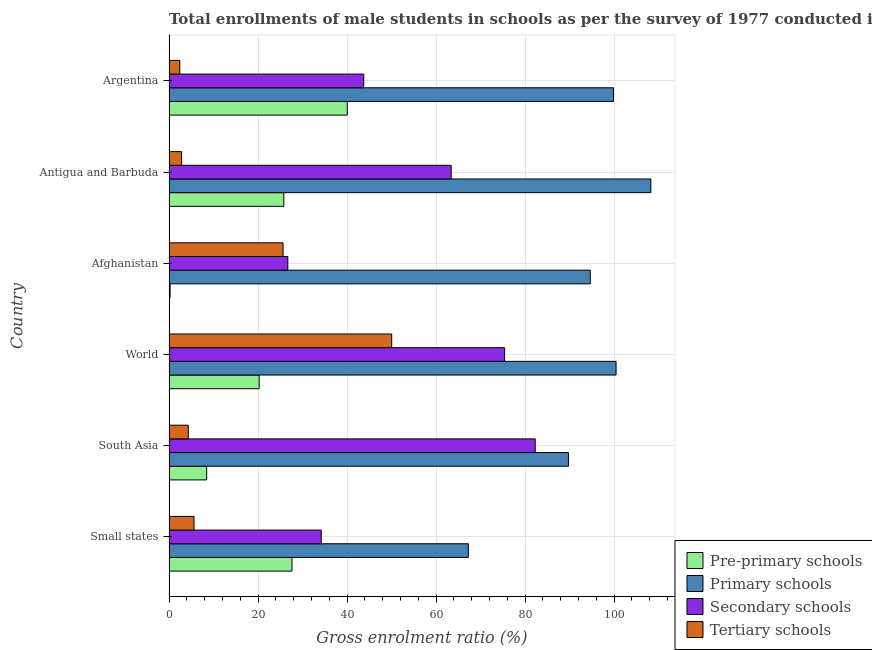How many groups of bars are there?
Give a very brief answer. 6. Are the number of bars per tick equal to the number of legend labels?
Make the answer very short. Yes. Are the number of bars on each tick of the Y-axis equal?
Your response must be concise. Yes. How many bars are there on the 3rd tick from the bottom?
Provide a succinct answer. 4. In how many cases, is the number of bars for a given country not equal to the number of legend labels?
Keep it short and to the point. 0. What is the gross enrolment ratio(male) in secondary schools in Small states?
Offer a terse response. 34.22. Across all countries, what is the maximum gross enrolment ratio(male) in tertiary schools?
Make the answer very short. 50.04. Across all countries, what is the minimum gross enrolment ratio(male) in secondary schools?
Your answer should be compact. 26.7. In which country was the gross enrolment ratio(male) in secondary schools minimum?
Provide a short and direct response. Afghanistan. What is the total gross enrolment ratio(male) in primary schools in the graph?
Ensure brevity in your answer.  560.32. What is the difference between the gross enrolment ratio(male) in pre-primary schools in Argentina and that in World?
Your answer should be very brief. 19.8. What is the difference between the gross enrolment ratio(male) in primary schools in South Asia and the gross enrolment ratio(male) in pre-primary schools in World?
Your response must be concise. 69.5. What is the average gross enrolment ratio(male) in tertiary schools per country?
Make the answer very short. 15.15. What is the difference between the gross enrolment ratio(male) in pre-primary schools and gross enrolment ratio(male) in tertiary schools in Antigua and Barbuda?
Offer a very short reply. 22.97. In how many countries, is the gross enrolment ratio(male) in pre-primary schools greater than 92 %?
Make the answer very short. 0. What is the ratio of the gross enrolment ratio(male) in primary schools in Antigua and Barbuda to that in Small states?
Ensure brevity in your answer.  1.61. Is the gross enrolment ratio(male) in pre-primary schools in Antigua and Barbuda less than that in Small states?
Your answer should be compact. Yes. What is the difference between the highest and the second highest gross enrolment ratio(male) in pre-primary schools?
Ensure brevity in your answer.  12.43. What is the difference between the highest and the lowest gross enrolment ratio(male) in secondary schools?
Keep it short and to the point. 55.6. In how many countries, is the gross enrolment ratio(male) in tertiary schools greater than the average gross enrolment ratio(male) in tertiary schools taken over all countries?
Provide a succinct answer. 2. Is it the case that in every country, the sum of the gross enrolment ratio(male) in secondary schools and gross enrolment ratio(male) in pre-primary schools is greater than the sum of gross enrolment ratio(male) in primary schools and gross enrolment ratio(male) in tertiary schools?
Your response must be concise. Yes. What does the 1st bar from the top in South Asia represents?
Offer a very short reply. Tertiary schools. What does the 2nd bar from the bottom in World represents?
Keep it short and to the point. Primary schools. How many bars are there?
Provide a succinct answer. 24. Does the graph contain any zero values?
Provide a short and direct response. No. Does the graph contain grids?
Offer a terse response. Yes. Where does the legend appear in the graph?
Ensure brevity in your answer.  Bottom right. How are the legend labels stacked?
Make the answer very short. Vertical. What is the title of the graph?
Offer a very short reply. Total enrollments of male students in schools as per the survey of 1977 conducted in different countries. What is the label or title of the X-axis?
Give a very brief answer. Gross enrolment ratio (%). What is the label or title of the Y-axis?
Your answer should be compact. Country. What is the Gross enrolment ratio (%) in Pre-primary schools in Small states?
Give a very brief answer. 27.63. What is the Gross enrolment ratio (%) of Primary schools in Small states?
Your answer should be very brief. 67.26. What is the Gross enrolment ratio (%) in Secondary schools in Small states?
Ensure brevity in your answer.  34.22. What is the Gross enrolment ratio (%) in Tertiary schools in Small states?
Offer a terse response. 5.62. What is the Gross enrolment ratio (%) in Pre-primary schools in South Asia?
Your answer should be compact. 8.46. What is the Gross enrolment ratio (%) of Primary schools in South Asia?
Your answer should be compact. 89.76. What is the Gross enrolment ratio (%) in Secondary schools in South Asia?
Keep it short and to the point. 82.29. What is the Gross enrolment ratio (%) of Tertiary schools in South Asia?
Offer a terse response. 4.33. What is the Gross enrolment ratio (%) of Pre-primary schools in World?
Provide a short and direct response. 20.26. What is the Gross enrolment ratio (%) of Primary schools in World?
Offer a terse response. 100.46. What is the Gross enrolment ratio (%) of Secondary schools in World?
Provide a succinct answer. 75.41. What is the Gross enrolment ratio (%) of Tertiary schools in World?
Give a very brief answer. 50.04. What is the Gross enrolment ratio (%) in Pre-primary schools in Afghanistan?
Make the answer very short. 0.25. What is the Gross enrolment ratio (%) in Primary schools in Afghanistan?
Give a very brief answer. 94.66. What is the Gross enrolment ratio (%) of Secondary schools in Afghanistan?
Provide a short and direct response. 26.7. What is the Gross enrolment ratio (%) of Tertiary schools in Afghanistan?
Your answer should be compact. 25.63. What is the Gross enrolment ratio (%) in Pre-primary schools in Antigua and Barbuda?
Keep it short and to the point. 25.8. What is the Gross enrolment ratio (%) in Primary schools in Antigua and Barbuda?
Give a very brief answer. 108.28. What is the Gross enrolment ratio (%) of Secondary schools in Antigua and Barbuda?
Provide a succinct answer. 63.41. What is the Gross enrolment ratio (%) of Tertiary schools in Antigua and Barbuda?
Offer a terse response. 2.84. What is the Gross enrolment ratio (%) in Pre-primary schools in Argentina?
Keep it short and to the point. 40.06. What is the Gross enrolment ratio (%) in Primary schools in Argentina?
Make the answer very short. 99.88. What is the Gross enrolment ratio (%) in Secondary schools in Argentina?
Keep it short and to the point. 43.76. What is the Gross enrolment ratio (%) in Tertiary schools in Argentina?
Your response must be concise. 2.43. Across all countries, what is the maximum Gross enrolment ratio (%) of Pre-primary schools?
Provide a short and direct response. 40.06. Across all countries, what is the maximum Gross enrolment ratio (%) in Primary schools?
Make the answer very short. 108.28. Across all countries, what is the maximum Gross enrolment ratio (%) of Secondary schools?
Give a very brief answer. 82.29. Across all countries, what is the maximum Gross enrolment ratio (%) in Tertiary schools?
Your response must be concise. 50.04. Across all countries, what is the minimum Gross enrolment ratio (%) in Pre-primary schools?
Your answer should be very brief. 0.25. Across all countries, what is the minimum Gross enrolment ratio (%) in Primary schools?
Offer a very short reply. 67.26. Across all countries, what is the minimum Gross enrolment ratio (%) in Secondary schools?
Keep it short and to the point. 26.7. Across all countries, what is the minimum Gross enrolment ratio (%) in Tertiary schools?
Your answer should be compact. 2.43. What is the total Gross enrolment ratio (%) in Pre-primary schools in the graph?
Provide a short and direct response. 122.47. What is the total Gross enrolment ratio (%) of Primary schools in the graph?
Your answer should be compact. 560.32. What is the total Gross enrolment ratio (%) of Secondary schools in the graph?
Provide a succinct answer. 325.79. What is the total Gross enrolment ratio (%) of Tertiary schools in the graph?
Make the answer very short. 90.89. What is the difference between the Gross enrolment ratio (%) of Pre-primary schools in Small states and that in South Asia?
Provide a short and direct response. 19.17. What is the difference between the Gross enrolment ratio (%) of Primary schools in Small states and that in South Asia?
Your answer should be compact. -22.51. What is the difference between the Gross enrolment ratio (%) of Secondary schools in Small states and that in South Asia?
Offer a terse response. -48.08. What is the difference between the Gross enrolment ratio (%) in Tertiary schools in Small states and that in South Asia?
Your response must be concise. 1.29. What is the difference between the Gross enrolment ratio (%) in Pre-primary schools in Small states and that in World?
Make the answer very short. 7.37. What is the difference between the Gross enrolment ratio (%) in Primary schools in Small states and that in World?
Your response must be concise. -33.21. What is the difference between the Gross enrolment ratio (%) of Secondary schools in Small states and that in World?
Make the answer very short. -41.2. What is the difference between the Gross enrolment ratio (%) in Tertiary schools in Small states and that in World?
Make the answer very short. -44.42. What is the difference between the Gross enrolment ratio (%) in Pre-primary schools in Small states and that in Afghanistan?
Provide a succinct answer. 27.38. What is the difference between the Gross enrolment ratio (%) of Primary schools in Small states and that in Afghanistan?
Your answer should be compact. -27.41. What is the difference between the Gross enrolment ratio (%) in Secondary schools in Small states and that in Afghanistan?
Your answer should be very brief. 7.52. What is the difference between the Gross enrolment ratio (%) of Tertiary schools in Small states and that in Afghanistan?
Give a very brief answer. -20.01. What is the difference between the Gross enrolment ratio (%) in Pre-primary schools in Small states and that in Antigua and Barbuda?
Your answer should be very brief. 1.82. What is the difference between the Gross enrolment ratio (%) in Primary schools in Small states and that in Antigua and Barbuda?
Provide a short and direct response. -41.03. What is the difference between the Gross enrolment ratio (%) of Secondary schools in Small states and that in Antigua and Barbuda?
Provide a succinct answer. -29.19. What is the difference between the Gross enrolment ratio (%) in Tertiary schools in Small states and that in Antigua and Barbuda?
Provide a succinct answer. 2.78. What is the difference between the Gross enrolment ratio (%) of Pre-primary schools in Small states and that in Argentina?
Offer a terse response. -12.43. What is the difference between the Gross enrolment ratio (%) of Primary schools in Small states and that in Argentina?
Make the answer very short. -32.63. What is the difference between the Gross enrolment ratio (%) of Secondary schools in Small states and that in Argentina?
Keep it short and to the point. -9.55. What is the difference between the Gross enrolment ratio (%) in Tertiary schools in Small states and that in Argentina?
Provide a short and direct response. 3.19. What is the difference between the Gross enrolment ratio (%) in Pre-primary schools in South Asia and that in World?
Make the answer very short. -11.8. What is the difference between the Gross enrolment ratio (%) of Primary schools in South Asia and that in World?
Provide a succinct answer. -10.7. What is the difference between the Gross enrolment ratio (%) of Secondary schools in South Asia and that in World?
Keep it short and to the point. 6.88. What is the difference between the Gross enrolment ratio (%) of Tertiary schools in South Asia and that in World?
Your answer should be very brief. -45.71. What is the difference between the Gross enrolment ratio (%) in Pre-primary schools in South Asia and that in Afghanistan?
Keep it short and to the point. 8.21. What is the difference between the Gross enrolment ratio (%) in Primary schools in South Asia and that in Afghanistan?
Your answer should be very brief. -4.9. What is the difference between the Gross enrolment ratio (%) in Secondary schools in South Asia and that in Afghanistan?
Provide a short and direct response. 55.6. What is the difference between the Gross enrolment ratio (%) in Tertiary schools in South Asia and that in Afghanistan?
Give a very brief answer. -21.3. What is the difference between the Gross enrolment ratio (%) in Pre-primary schools in South Asia and that in Antigua and Barbuda?
Keep it short and to the point. -17.34. What is the difference between the Gross enrolment ratio (%) in Primary schools in South Asia and that in Antigua and Barbuda?
Offer a very short reply. -18.52. What is the difference between the Gross enrolment ratio (%) in Secondary schools in South Asia and that in Antigua and Barbuda?
Offer a terse response. 18.89. What is the difference between the Gross enrolment ratio (%) of Tertiary schools in South Asia and that in Antigua and Barbuda?
Give a very brief answer. 1.49. What is the difference between the Gross enrolment ratio (%) of Pre-primary schools in South Asia and that in Argentina?
Provide a succinct answer. -31.6. What is the difference between the Gross enrolment ratio (%) of Primary schools in South Asia and that in Argentina?
Ensure brevity in your answer.  -10.12. What is the difference between the Gross enrolment ratio (%) of Secondary schools in South Asia and that in Argentina?
Make the answer very short. 38.53. What is the difference between the Gross enrolment ratio (%) in Tertiary schools in South Asia and that in Argentina?
Ensure brevity in your answer.  1.9. What is the difference between the Gross enrolment ratio (%) in Pre-primary schools in World and that in Afghanistan?
Offer a terse response. 20.01. What is the difference between the Gross enrolment ratio (%) of Primary schools in World and that in Afghanistan?
Keep it short and to the point. 5.8. What is the difference between the Gross enrolment ratio (%) in Secondary schools in World and that in Afghanistan?
Your answer should be compact. 48.72. What is the difference between the Gross enrolment ratio (%) of Tertiary schools in World and that in Afghanistan?
Offer a very short reply. 24.41. What is the difference between the Gross enrolment ratio (%) in Pre-primary schools in World and that in Antigua and Barbuda?
Provide a short and direct response. -5.54. What is the difference between the Gross enrolment ratio (%) of Primary schools in World and that in Antigua and Barbuda?
Keep it short and to the point. -7.82. What is the difference between the Gross enrolment ratio (%) of Secondary schools in World and that in Antigua and Barbuda?
Your answer should be compact. 12.01. What is the difference between the Gross enrolment ratio (%) of Tertiary schools in World and that in Antigua and Barbuda?
Make the answer very short. 47.2. What is the difference between the Gross enrolment ratio (%) in Pre-primary schools in World and that in Argentina?
Your answer should be very brief. -19.8. What is the difference between the Gross enrolment ratio (%) in Primary schools in World and that in Argentina?
Ensure brevity in your answer.  0.58. What is the difference between the Gross enrolment ratio (%) of Secondary schools in World and that in Argentina?
Offer a very short reply. 31.65. What is the difference between the Gross enrolment ratio (%) in Tertiary schools in World and that in Argentina?
Offer a very short reply. 47.61. What is the difference between the Gross enrolment ratio (%) in Pre-primary schools in Afghanistan and that in Antigua and Barbuda?
Make the answer very short. -25.56. What is the difference between the Gross enrolment ratio (%) in Primary schools in Afghanistan and that in Antigua and Barbuda?
Ensure brevity in your answer.  -13.62. What is the difference between the Gross enrolment ratio (%) in Secondary schools in Afghanistan and that in Antigua and Barbuda?
Your answer should be compact. -36.71. What is the difference between the Gross enrolment ratio (%) in Tertiary schools in Afghanistan and that in Antigua and Barbuda?
Offer a terse response. 22.79. What is the difference between the Gross enrolment ratio (%) of Pre-primary schools in Afghanistan and that in Argentina?
Your answer should be compact. -39.81. What is the difference between the Gross enrolment ratio (%) of Primary schools in Afghanistan and that in Argentina?
Give a very brief answer. -5.22. What is the difference between the Gross enrolment ratio (%) of Secondary schools in Afghanistan and that in Argentina?
Give a very brief answer. -17.07. What is the difference between the Gross enrolment ratio (%) of Tertiary schools in Afghanistan and that in Argentina?
Give a very brief answer. 23.2. What is the difference between the Gross enrolment ratio (%) in Pre-primary schools in Antigua and Barbuda and that in Argentina?
Offer a terse response. -14.26. What is the difference between the Gross enrolment ratio (%) in Primary schools in Antigua and Barbuda and that in Argentina?
Offer a very short reply. 8.4. What is the difference between the Gross enrolment ratio (%) in Secondary schools in Antigua and Barbuda and that in Argentina?
Your answer should be very brief. 19.64. What is the difference between the Gross enrolment ratio (%) of Tertiary schools in Antigua and Barbuda and that in Argentina?
Offer a terse response. 0.41. What is the difference between the Gross enrolment ratio (%) of Pre-primary schools in Small states and the Gross enrolment ratio (%) of Primary schools in South Asia?
Offer a very short reply. -62.14. What is the difference between the Gross enrolment ratio (%) of Pre-primary schools in Small states and the Gross enrolment ratio (%) of Secondary schools in South Asia?
Your response must be concise. -54.66. What is the difference between the Gross enrolment ratio (%) of Pre-primary schools in Small states and the Gross enrolment ratio (%) of Tertiary schools in South Asia?
Make the answer very short. 23.3. What is the difference between the Gross enrolment ratio (%) in Primary schools in Small states and the Gross enrolment ratio (%) in Secondary schools in South Asia?
Your response must be concise. -15.04. What is the difference between the Gross enrolment ratio (%) of Primary schools in Small states and the Gross enrolment ratio (%) of Tertiary schools in South Asia?
Ensure brevity in your answer.  62.93. What is the difference between the Gross enrolment ratio (%) of Secondary schools in Small states and the Gross enrolment ratio (%) of Tertiary schools in South Asia?
Keep it short and to the point. 29.89. What is the difference between the Gross enrolment ratio (%) of Pre-primary schools in Small states and the Gross enrolment ratio (%) of Primary schools in World?
Your response must be concise. -72.83. What is the difference between the Gross enrolment ratio (%) in Pre-primary schools in Small states and the Gross enrolment ratio (%) in Secondary schools in World?
Your answer should be compact. -47.79. What is the difference between the Gross enrolment ratio (%) in Pre-primary schools in Small states and the Gross enrolment ratio (%) in Tertiary schools in World?
Ensure brevity in your answer.  -22.41. What is the difference between the Gross enrolment ratio (%) in Primary schools in Small states and the Gross enrolment ratio (%) in Secondary schools in World?
Ensure brevity in your answer.  -8.16. What is the difference between the Gross enrolment ratio (%) in Primary schools in Small states and the Gross enrolment ratio (%) in Tertiary schools in World?
Make the answer very short. 17.22. What is the difference between the Gross enrolment ratio (%) of Secondary schools in Small states and the Gross enrolment ratio (%) of Tertiary schools in World?
Offer a very short reply. -15.82. What is the difference between the Gross enrolment ratio (%) of Pre-primary schools in Small states and the Gross enrolment ratio (%) of Primary schools in Afghanistan?
Your answer should be compact. -67.03. What is the difference between the Gross enrolment ratio (%) of Pre-primary schools in Small states and the Gross enrolment ratio (%) of Secondary schools in Afghanistan?
Provide a short and direct response. 0.93. What is the difference between the Gross enrolment ratio (%) in Pre-primary schools in Small states and the Gross enrolment ratio (%) in Tertiary schools in Afghanistan?
Offer a terse response. 2. What is the difference between the Gross enrolment ratio (%) of Primary schools in Small states and the Gross enrolment ratio (%) of Secondary schools in Afghanistan?
Offer a terse response. 40.56. What is the difference between the Gross enrolment ratio (%) in Primary schools in Small states and the Gross enrolment ratio (%) in Tertiary schools in Afghanistan?
Your answer should be very brief. 41.63. What is the difference between the Gross enrolment ratio (%) of Secondary schools in Small states and the Gross enrolment ratio (%) of Tertiary schools in Afghanistan?
Offer a very short reply. 8.59. What is the difference between the Gross enrolment ratio (%) of Pre-primary schools in Small states and the Gross enrolment ratio (%) of Primary schools in Antigua and Barbuda?
Make the answer very short. -80.65. What is the difference between the Gross enrolment ratio (%) in Pre-primary schools in Small states and the Gross enrolment ratio (%) in Secondary schools in Antigua and Barbuda?
Offer a very short reply. -35.78. What is the difference between the Gross enrolment ratio (%) of Pre-primary schools in Small states and the Gross enrolment ratio (%) of Tertiary schools in Antigua and Barbuda?
Give a very brief answer. 24.79. What is the difference between the Gross enrolment ratio (%) in Primary schools in Small states and the Gross enrolment ratio (%) in Secondary schools in Antigua and Barbuda?
Your answer should be very brief. 3.85. What is the difference between the Gross enrolment ratio (%) in Primary schools in Small states and the Gross enrolment ratio (%) in Tertiary schools in Antigua and Barbuda?
Make the answer very short. 64.42. What is the difference between the Gross enrolment ratio (%) in Secondary schools in Small states and the Gross enrolment ratio (%) in Tertiary schools in Antigua and Barbuda?
Ensure brevity in your answer.  31.38. What is the difference between the Gross enrolment ratio (%) of Pre-primary schools in Small states and the Gross enrolment ratio (%) of Primary schools in Argentina?
Provide a succinct answer. -72.25. What is the difference between the Gross enrolment ratio (%) of Pre-primary schools in Small states and the Gross enrolment ratio (%) of Secondary schools in Argentina?
Make the answer very short. -16.13. What is the difference between the Gross enrolment ratio (%) in Pre-primary schools in Small states and the Gross enrolment ratio (%) in Tertiary schools in Argentina?
Give a very brief answer. 25.2. What is the difference between the Gross enrolment ratio (%) in Primary schools in Small states and the Gross enrolment ratio (%) in Secondary schools in Argentina?
Offer a terse response. 23.5. What is the difference between the Gross enrolment ratio (%) of Primary schools in Small states and the Gross enrolment ratio (%) of Tertiary schools in Argentina?
Provide a succinct answer. 64.83. What is the difference between the Gross enrolment ratio (%) in Secondary schools in Small states and the Gross enrolment ratio (%) in Tertiary schools in Argentina?
Offer a very short reply. 31.79. What is the difference between the Gross enrolment ratio (%) in Pre-primary schools in South Asia and the Gross enrolment ratio (%) in Primary schools in World?
Offer a very short reply. -92. What is the difference between the Gross enrolment ratio (%) of Pre-primary schools in South Asia and the Gross enrolment ratio (%) of Secondary schools in World?
Provide a succinct answer. -66.95. What is the difference between the Gross enrolment ratio (%) of Pre-primary schools in South Asia and the Gross enrolment ratio (%) of Tertiary schools in World?
Offer a terse response. -41.58. What is the difference between the Gross enrolment ratio (%) of Primary schools in South Asia and the Gross enrolment ratio (%) of Secondary schools in World?
Provide a succinct answer. 14.35. What is the difference between the Gross enrolment ratio (%) of Primary schools in South Asia and the Gross enrolment ratio (%) of Tertiary schools in World?
Your response must be concise. 39.72. What is the difference between the Gross enrolment ratio (%) of Secondary schools in South Asia and the Gross enrolment ratio (%) of Tertiary schools in World?
Offer a terse response. 32.25. What is the difference between the Gross enrolment ratio (%) of Pre-primary schools in South Asia and the Gross enrolment ratio (%) of Primary schools in Afghanistan?
Give a very brief answer. -86.2. What is the difference between the Gross enrolment ratio (%) of Pre-primary schools in South Asia and the Gross enrolment ratio (%) of Secondary schools in Afghanistan?
Make the answer very short. -18.24. What is the difference between the Gross enrolment ratio (%) in Pre-primary schools in South Asia and the Gross enrolment ratio (%) in Tertiary schools in Afghanistan?
Provide a succinct answer. -17.17. What is the difference between the Gross enrolment ratio (%) in Primary schools in South Asia and the Gross enrolment ratio (%) in Secondary schools in Afghanistan?
Your answer should be very brief. 63.07. What is the difference between the Gross enrolment ratio (%) in Primary schools in South Asia and the Gross enrolment ratio (%) in Tertiary schools in Afghanistan?
Give a very brief answer. 64.13. What is the difference between the Gross enrolment ratio (%) in Secondary schools in South Asia and the Gross enrolment ratio (%) in Tertiary schools in Afghanistan?
Provide a short and direct response. 56.66. What is the difference between the Gross enrolment ratio (%) in Pre-primary schools in South Asia and the Gross enrolment ratio (%) in Primary schools in Antigua and Barbuda?
Offer a very short reply. -99.82. What is the difference between the Gross enrolment ratio (%) in Pre-primary schools in South Asia and the Gross enrolment ratio (%) in Secondary schools in Antigua and Barbuda?
Your answer should be compact. -54.95. What is the difference between the Gross enrolment ratio (%) of Pre-primary schools in South Asia and the Gross enrolment ratio (%) of Tertiary schools in Antigua and Barbuda?
Your response must be concise. 5.62. What is the difference between the Gross enrolment ratio (%) of Primary schools in South Asia and the Gross enrolment ratio (%) of Secondary schools in Antigua and Barbuda?
Offer a terse response. 26.36. What is the difference between the Gross enrolment ratio (%) in Primary schools in South Asia and the Gross enrolment ratio (%) in Tertiary schools in Antigua and Barbuda?
Give a very brief answer. 86.93. What is the difference between the Gross enrolment ratio (%) in Secondary schools in South Asia and the Gross enrolment ratio (%) in Tertiary schools in Antigua and Barbuda?
Give a very brief answer. 79.46. What is the difference between the Gross enrolment ratio (%) in Pre-primary schools in South Asia and the Gross enrolment ratio (%) in Primary schools in Argentina?
Ensure brevity in your answer.  -91.42. What is the difference between the Gross enrolment ratio (%) in Pre-primary schools in South Asia and the Gross enrolment ratio (%) in Secondary schools in Argentina?
Make the answer very short. -35.3. What is the difference between the Gross enrolment ratio (%) in Pre-primary schools in South Asia and the Gross enrolment ratio (%) in Tertiary schools in Argentina?
Your answer should be very brief. 6.03. What is the difference between the Gross enrolment ratio (%) of Primary schools in South Asia and the Gross enrolment ratio (%) of Secondary schools in Argentina?
Make the answer very short. 46. What is the difference between the Gross enrolment ratio (%) of Primary schools in South Asia and the Gross enrolment ratio (%) of Tertiary schools in Argentina?
Your answer should be very brief. 87.33. What is the difference between the Gross enrolment ratio (%) in Secondary schools in South Asia and the Gross enrolment ratio (%) in Tertiary schools in Argentina?
Provide a succinct answer. 79.86. What is the difference between the Gross enrolment ratio (%) in Pre-primary schools in World and the Gross enrolment ratio (%) in Primary schools in Afghanistan?
Offer a terse response. -74.4. What is the difference between the Gross enrolment ratio (%) of Pre-primary schools in World and the Gross enrolment ratio (%) of Secondary schools in Afghanistan?
Offer a very short reply. -6.43. What is the difference between the Gross enrolment ratio (%) in Pre-primary schools in World and the Gross enrolment ratio (%) in Tertiary schools in Afghanistan?
Your response must be concise. -5.37. What is the difference between the Gross enrolment ratio (%) in Primary schools in World and the Gross enrolment ratio (%) in Secondary schools in Afghanistan?
Offer a terse response. 73.77. What is the difference between the Gross enrolment ratio (%) in Primary schools in World and the Gross enrolment ratio (%) in Tertiary schools in Afghanistan?
Ensure brevity in your answer.  74.83. What is the difference between the Gross enrolment ratio (%) of Secondary schools in World and the Gross enrolment ratio (%) of Tertiary schools in Afghanistan?
Make the answer very short. 49.78. What is the difference between the Gross enrolment ratio (%) in Pre-primary schools in World and the Gross enrolment ratio (%) in Primary schools in Antigua and Barbuda?
Your response must be concise. -88.02. What is the difference between the Gross enrolment ratio (%) of Pre-primary schools in World and the Gross enrolment ratio (%) of Secondary schools in Antigua and Barbuda?
Offer a terse response. -43.14. What is the difference between the Gross enrolment ratio (%) in Pre-primary schools in World and the Gross enrolment ratio (%) in Tertiary schools in Antigua and Barbuda?
Keep it short and to the point. 17.43. What is the difference between the Gross enrolment ratio (%) of Primary schools in World and the Gross enrolment ratio (%) of Secondary schools in Antigua and Barbuda?
Make the answer very short. 37.06. What is the difference between the Gross enrolment ratio (%) of Primary schools in World and the Gross enrolment ratio (%) of Tertiary schools in Antigua and Barbuda?
Offer a terse response. 97.63. What is the difference between the Gross enrolment ratio (%) of Secondary schools in World and the Gross enrolment ratio (%) of Tertiary schools in Antigua and Barbuda?
Offer a very short reply. 72.58. What is the difference between the Gross enrolment ratio (%) of Pre-primary schools in World and the Gross enrolment ratio (%) of Primary schools in Argentina?
Your answer should be compact. -79.62. What is the difference between the Gross enrolment ratio (%) of Pre-primary schools in World and the Gross enrolment ratio (%) of Secondary schools in Argentina?
Your response must be concise. -23.5. What is the difference between the Gross enrolment ratio (%) of Pre-primary schools in World and the Gross enrolment ratio (%) of Tertiary schools in Argentina?
Ensure brevity in your answer.  17.83. What is the difference between the Gross enrolment ratio (%) in Primary schools in World and the Gross enrolment ratio (%) in Secondary schools in Argentina?
Your answer should be very brief. 56.7. What is the difference between the Gross enrolment ratio (%) in Primary schools in World and the Gross enrolment ratio (%) in Tertiary schools in Argentina?
Keep it short and to the point. 98.03. What is the difference between the Gross enrolment ratio (%) in Secondary schools in World and the Gross enrolment ratio (%) in Tertiary schools in Argentina?
Make the answer very short. 72.98. What is the difference between the Gross enrolment ratio (%) of Pre-primary schools in Afghanistan and the Gross enrolment ratio (%) of Primary schools in Antigua and Barbuda?
Your response must be concise. -108.03. What is the difference between the Gross enrolment ratio (%) in Pre-primary schools in Afghanistan and the Gross enrolment ratio (%) in Secondary schools in Antigua and Barbuda?
Ensure brevity in your answer.  -63.16. What is the difference between the Gross enrolment ratio (%) of Pre-primary schools in Afghanistan and the Gross enrolment ratio (%) of Tertiary schools in Antigua and Barbuda?
Offer a terse response. -2.59. What is the difference between the Gross enrolment ratio (%) in Primary schools in Afghanistan and the Gross enrolment ratio (%) in Secondary schools in Antigua and Barbuda?
Ensure brevity in your answer.  31.26. What is the difference between the Gross enrolment ratio (%) in Primary schools in Afghanistan and the Gross enrolment ratio (%) in Tertiary schools in Antigua and Barbuda?
Your answer should be very brief. 91.83. What is the difference between the Gross enrolment ratio (%) in Secondary schools in Afghanistan and the Gross enrolment ratio (%) in Tertiary schools in Antigua and Barbuda?
Ensure brevity in your answer.  23.86. What is the difference between the Gross enrolment ratio (%) of Pre-primary schools in Afghanistan and the Gross enrolment ratio (%) of Primary schools in Argentina?
Offer a very short reply. -99.63. What is the difference between the Gross enrolment ratio (%) in Pre-primary schools in Afghanistan and the Gross enrolment ratio (%) in Secondary schools in Argentina?
Your response must be concise. -43.51. What is the difference between the Gross enrolment ratio (%) of Pre-primary schools in Afghanistan and the Gross enrolment ratio (%) of Tertiary schools in Argentina?
Provide a succinct answer. -2.18. What is the difference between the Gross enrolment ratio (%) in Primary schools in Afghanistan and the Gross enrolment ratio (%) in Secondary schools in Argentina?
Provide a short and direct response. 50.9. What is the difference between the Gross enrolment ratio (%) in Primary schools in Afghanistan and the Gross enrolment ratio (%) in Tertiary schools in Argentina?
Your answer should be compact. 92.23. What is the difference between the Gross enrolment ratio (%) in Secondary schools in Afghanistan and the Gross enrolment ratio (%) in Tertiary schools in Argentina?
Keep it short and to the point. 24.27. What is the difference between the Gross enrolment ratio (%) in Pre-primary schools in Antigua and Barbuda and the Gross enrolment ratio (%) in Primary schools in Argentina?
Give a very brief answer. -74.08. What is the difference between the Gross enrolment ratio (%) in Pre-primary schools in Antigua and Barbuda and the Gross enrolment ratio (%) in Secondary schools in Argentina?
Provide a short and direct response. -17.96. What is the difference between the Gross enrolment ratio (%) of Pre-primary schools in Antigua and Barbuda and the Gross enrolment ratio (%) of Tertiary schools in Argentina?
Keep it short and to the point. 23.37. What is the difference between the Gross enrolment ratio (%) of Primary schools in Antigua and Barbuda and the Gross enrolment ratio (%) of Secondary schools in Argentina?
Keep it short and to the point. 64.52. What is the difference between the Gross enrolment ratio (%) of Primary schools in Antigua and Barbuda and the Gross enrolment ratio (%) of Tertiary schools in Argentina?
Offer a very short reply. 105.85. What is the difference between the Gross enrolment ratio (%) of Secondary schools in Antigua and Barbuda and the Gross enrolment ratio (%) of Tertiary schools in Argentina?
Give a very brief answer. 60.98. What is the average Gross enrolment ratio (%) of Pre-primary schools per country?
Your response must be concise. 20.41. What is the average Gross enrolment ratio (%) of Primary schools per country?
Ensure brevity in your answer.  93.39. What is the average Gross enrolment ratio (%) in Secondary schools per country?
Offer a terse response. 54.3. What is the average Gross enrolment ratio (%) in Tertiary schools per country?
Provide a succinct answer. 15.15. What is the difference between the Gross enrolment ratio (%) in Pre-primary schools and Gross enrolment ratio (%) in Primary schools in Small states?
Make the answer very short. -39.63. What is the difference between the Gross enrolment ratio (%) in Pre-primary schools and Gross enrolment ratio (%) in Secondary schools in Small states?
Keep it short and to the point. -6.59. What is the difference between the Gross enrolment ratio (%) of Pre-primary schools and Gross enrolment ratio (%) of Tertiary schools in Small states?
Offer a terse response. 22.01. What is the difference between the Gross enrolment ratio (%) in Primary schools and Gross enrolment ratio (%) in Secondary schools in Small states?
Your answer should be compact. 33.04. What is the difference between the Gross enrolment ratio (%) of Primary schools and Gross enrolment ratio (%) of Tertiary schools in Small states?
Your answer should be very brief. 61.64. What is the difference between the Gross enrolment ratio (%) of Secondary schools and Gross enrolment ratio (%) of Tertiary schools in Small states?
Offer a very short reply. 28.6. What is the difference between the Gross enrolment ratio (%) of Pre-primary schools and Gross enrolment ratio (%) of Primary schools in South Asia?
Offer a very short reply. -81.3. What is the difference between the Gross enrolment ratio (%) in Pre-primary schools and Gross enrolment ratio (%) in Secondary schools in South Asia?
Your answer should be compact. -73.83. What is the difference between the Gross enrolment ratio (%) of Pre-primary schools and Gross enrolment ratio (%) of Tertiary schools in South Asia?
Provide a short and direct response. 4.13. What is the difference between the Gross enrolment ratio (%) in Primary schools and Gross enrolment ratio (%) in Secondary schools in South Asia?
Keep it short and to the point. 7.47. What is the difference between the Gross enrolment ratio (%) of Primary schools and Gross enrolment ratio (%) of Tertiary schools in South Asia?
Ensure brevity in your answer.  85.43. What is the difference between the Gross enrolment ratio (%) in Secondary schools and Gross enrolment ratio (%) in Tertiary schools in South Asia?
Your answer should be very brief. 77.96. What is the difference between the Gross enrolment ratio (%) in Pre-primary schools and Gross enrolment ratio (%) in Primary schools in World?
Give a very brief answer. -80.2. What is the difference between the Gross enrolment ratio (%) of Pre-primary schools and Gross enrolment ratio (%) of Secondary schools in World?
Offer a terse response. -55.15. What is the difference between the Gross enrolment ratio (%) of Pre-primary schools and Gross enrolment ratio (%) of Tertiary schools in World?
Offer a very short reply. -29.78. What is the difference between the Gross enrolment ratio (%) of Primary schools and Gross enrolment ratio (%) of Secondary schools in World?
Ensure brevity in your answer.  25.05. What is the difference between the Gross enrolment ratio (%) of Primary schools and Gross enrolment ratio (%) of Tertiary schools in World?
Offer a terse response. 50.42. What is the difference between the Gross enrolment ratio (%) in Secondary schools and Gross enrolment ratio (%) in Tertiary schools in World?
Make the answer very short. 25.37. What is the difference between the Gross enrolment ratio (%) in Pre-primary schools and Gross enrolment ratio (%) in Primary schools in Afghanistan?
Give a very brief answer. -94.42. What is the difference between the Gross enrolment ratio (%) of Pre-primary schools and Gross enrolment ratio (%) of Secondary schools in Afghanistan?
Make the answer very short. -26.45. What is the difference between the Gross enrolment ratio (%) in Pre-primary schools and Gross enrolment ratio (%) in Tertiary schools in Afghanistan?
Offer a very short reply. -25.38. What is the difference between the Gross enrolment ratio (%) of Primary schools and Gross enrolment ratio (%) of Secondary schools in Afghanistan?
Your answer should be very brief. 67.97. What is the difference between the Gross enrolment ratio (%) in Primary schools and Gross enrolment ratio (%) in Tertiary schools in Afghanistan?
Provide a succinct answer. 69.03. What is the difference between the Gross enrolment ratio (%) in Secondary schools and Gross enrolment ratio (%) in Tertiary schools in Afghanistan?
Provide a short and direct response. 1.07. What is the difference between the Gross enrolment ratio (%) in Pre-primary schools and Gross enrolment ratio (%) in Primary schools in Antigua and Barbuda?
Provide a short and direct response. -82.48. What is the difference between the Gross enrolment ratio (%) of Pre-primary schools and Gross enrolment ratio (%) of Secondary schools in Antigua and Barbuda?
Keep it short and to the point. -37.6. What is the difference between the Gross enrolment ratio (%) in Pre-primary schools and Gross enrolment ratio (%) in Tertiary schools in Antigua and Barbuda?
Ensure brevity in your answer.  22.97. What is the difference between the Gross enrolment ratio (%) of Primary schools and Gross enrolment ratio (%) of Secondary schools in Antigua and Barbuda?
Offer a very short reply. 44.88. What is the difference between the Gross enrolment ratio (%) in Primary schools and Gross enrolment ratio (%) in Tertiary schools in Antigua and Barbuda?
Ensure brevity in your answer.  105.45. What is the difference between the Gross enrolment ratio (%) of Secondary schools and Gross enrolment ratio (%) of Tertiary schools in Antigua and Barbuda?
Make the answer very short. 60.57. What is the difference between the Gross enrolment ratio (%) in Pre-primary schools and Gross enrolment ratio (%) in Primary schools in Argentina?
Keep it short and to the point. -59.82. What is the difference between the Gross enrolment ratio (%) of Pre-primary schools and Gross enrolment ratio (%) of Secondary schools in Argentina?
Your answer should be compact. -3.7. What is the difference between the Gross enrolment ratio (%) of Pre-primary schools and Gross enrolment ratio (%) of Tertiary schools in Argentina?
Your answer should be compact. 37.63. What is the difference between the Gross enrolment ratio (%) in Primary schools and Gross enrolment ratio (%) in Secondary schools in Argentina?
Give a very brief answer. 56.12. What is the difference between the Gross enrolment ratio (%) in Primary schools and Gross enrolment ratio (%) in Tertiary schools in Argentina?
Provide a succinct answer. 97.45. What is the difference between the Gross enrolment ratio (%) in Secondary schools and Gross enrolment ratio (%) in Tertiary schools in Argentina?
Your response must be concise. 41.33. What is the ratio of the Gross enrolment ratio (%) of Pre-primary schools in Small states to that in South Asia?
Your answer should be compact. 3.27. What is the ratio of the Gross enrolment ratio (%) in Primary schools in Small states to that in South Asia?
Offer a very short reply. 0.75. What is the ratio of the Gross enrolment ratio (%) of Secondary schools in Small states to that in South Asia?
Offer a terse response. 0.42. What is the ratio of the Gross enrolment ratio (%) of Tertiary schools in Small states to that in South Asia?
Your answer should be compact. 1.3. What is the ratio of the Gross enrolment ratio (%) of Pre-primary schools in Small states to that in World?
Give a very brief answer. 1.36. What is the ratio of the Gross enrolment ratio (%) of Primary schools in Small states to that in World?
Your answer should be very brief. 0.67. What is the ratio of the Gross enrolment ratio (%) of Secondary schools in Small states to that in World?
Provide a succinct answer. 0.45. What is the ratio of the Gross enrolment ratio (%) of Tertiary schools in Small states to that in World?
Provide a short and direct response. 0.11. What is the ratio of the Gross enrolment ratio (%) of Pre-primary schools in Small states to that in Afghanistan?
Make the answer very short. 110.82. What is the ratio of the Gross enrolment ratio (%) in Primary schools in Small states to that in Afghanistan?
Give a very brief answer. 0.71. What is the ratio of the Gross enrolment ratio (%) of Secondary schools in Small states to that in Afghanistan?
Your response must be concise. 1.28. What is the ratio of the Gross enrolment ratio (%) of Tertiary schools in Small states to that in Afghanistan?
Your response must be concise. 0.22. What is the ratio of the Gross enrolment ratio (%) of Pre-primary schools in Small states to that in Antigua and Barbuda?
Ensure brevity in your answer.  1.07. What is the ratio of the Gross enrolment ratio (%) of Primary schools in Small states to that in Antigua and Barbuda?
Offer a terse response. 0.62. What is the ratio of the Gross enrolment ratio (%) of Secondary schools in Small states to that in Antigua and Barbuda?
Make the answer very short. 0.54. What is the ratio of the Gross enrolment ratio (%) in Tertiary schools in Small states to that in Antigua and Barbuda?
Ensure brevity in your answer.  1.98. What is the ratio of the Gross enrolment ratio (%) of Pre-primary schools in Small states to that in Argentina?
Ensure brevity in your answer.  0.69. What is the ratio of the Gross enrolment ratio (%) in Primary schools in Small states to that in Argentina?
Keep it short and to the point. 0.67. What is the ratio of the Gross enrolment ratio (%) in Secondary schools in Small states to that in Argentina?
Provide a succinct answer. 0.78. What is the ratio of the Gross enrolment ratio (%) in Tertiary schools in Small states to that in Argentina?
Give a very brief answer. 2.31. What is the ratio of the Gross enrolment ratio (%) of Pre-primary schools in South Asia to that in World?
Provide a short and direct response. 0.42. What is the ratio of the Gross enrolment ratio (%) of Primary schools in South Asia to that in World?
Offer a very short reply. 0.89. What is the ratio of the Gross enrolment ratio (%) in Secondary schools in South Asia to that in World?
Offer a very short reply. 1.09. What is the ratio of the Gross enrolment ratio (%) in Tertiary schools in South Asia to that in World?
Make the answer very short. 0.09. What is the ratio of the Gross enrolment ratio (%) in Pre-primary schools in South Asia to that in Afghanistan?
Provide a succinct answer. 33.93. What is the ratio of the Gross enrolment ratio (%) in Primary schools in South Asia to that in Afghanistan?
Offer a very short reply. 0.95. What is the ratio of the Gross enrolment ratio (%) in Secondary schools in South Asia to that in Afghanistan?
Keep it short and to the point. 3.08. What is the ratio of the Gross enrolment ratio (%) of Tertiary schools in South Asia to that in Afghanistan?
Make the answer very short. 0.17. What is the ratio of the Gross enrolment ratio (%) of Pre-primary schools in South Asia to that in Antigua and Barbuda?
Offer a terse response. 0.33. What is the ratio of the Gross enrolment ratio (%) of Primary schools in South Asia to that in Antigua and Barbuda?
Make the answer very short. 0.83. What is the ratio of the Gross enrolment ratio (%) of Secondary schools in South Asia to that in Antigua and Barbuda?
Give a very brief answer. 1.3. What is the ratio of the Gross enrolment ratio (%) of Tertiary schools in South Asia to that in Antigua and Barbuda?
Your answer should be compact. 1.53. What is the ratio of the Gross enrolment ratio (%) in Pre-primary schools in South Asia to that in Argentina?
Give a very brief answer. 0.21. What is the ratio of the Gross enrolment ratio (%) of Primary schools in South Asia to that in Argentina?
Your response must be concise. 0.9. What is the ratio of the Gross enrolment ratio (%) of Secondary schools in South Asia to that in Argentina?
Provide a short and direct response. 1.88. What is the ratio of the Gross enrolment ratio (%) in Tertiary schools in South Asia to that in Argentina?
Give a very brief answer. 1.78. What is the ratio of the Gross enrolment ratio (%) of Pre-primary schools in World to that in Afghanistan?
Keep it short and to the point. 81.28. What is the ratio of the Gross enrolment ratio (%) in Primary schools in World to that in Afghanistan?
Make the answer very short. 1.06. What is the ratio of the Gross enrolment ratio (%) in Secondary schools in World to that in Afghanistan?
Offer a terse response. 2.82. What is the ratio of the Gross enrolment ratio (%) of Tertiary schools in World to that in Afghanistan?
Give a very brief answer. 1.95. What is the ratio of the Gross enrolment ratio (%) of Pre-primary schools in World to that in Antigua and Barbuda?
Your answer should be compact. 0.79. What is the ratio of the Gross enrolment ratio (%) in Primary schools in World to that in Antigua and Barbuda?
Give a very brief answer. 0.93. What is the ratio of the Gross enrolment ratio (%) in Secondary schools in World to that in Antigua and Barbuda?
Give a very brief answer. 1.19. What is the ratio of the Gross enrolment ratio (%) of Tertiary schools in World to that in Antigua and Barbuda?
Give a very brief answer. 17.63. What is the ratio of the Gross enrolment ratio (%) in Pre-primary schools in World to that in Argentina?
Offer a terse response. 0.51. What is the ratio of the Gross enrolment ratio (%) in Primary schools in World to that in Argentina?
Your answer should be compact. 1.01. What is the ratio of the Gross enrolment ratio (%) of Secondary schools in World to that in Argentina?
Keep it short and to the point. 1.72. What is the ratio of the Gross enrolment ratio (%) of Tertiary schools in World to that in Argentina?
Give a very brief answer. 20.59. What is the ratio of the Gross enrolment ratio (%) in Pre-primary schools in Afghanistan to that in Antigua and Barbuda?
Provide a short and direct response. 0.01. What is the ratio of the Gross enrolment ratio (%) in Primary schools in Afghanistan to that in Antigua and Barbuda?
Offer a very short reply. 0.87. What is the ratio of the Gross enrolment ratio (%) in Secondary schools in Afghanistan to that in Antigua and Barbuda?
Your response must be concise. 0.42. What is the ratio of the Gross enrolment ratio (%) in Tertiary schools in Afghanistan to that in Antigua and Barbuda?
Keep it short and to the point. 9.03. What is the ratio of the Gross enrolment ratio (%) of Pre-primary schools in Afghanistan to that in Argentina?
Your answer should be compact. 0.01. What is the ratio of the Gross enrolment ratio (%) in Primary schools in Afghanistan to that in Argentina?
Make the answer very short. 0.95. What is the ratio of the Gross enrolment ratio (%) in Secondary schools in Afghanistan to that in Argentina?
Give a very brief answer. 0.61. What is the ratio of the Gross enrolment ratio (%) of Tertiary schools in Afghanistan to that in Argentina?
Provide a succinct answer. 10.55. What is the ratio of the Gross enrolment ratio (%) of Pre-primary schools in Antigua and Barbuda to that in Argentina?
Keep it short and to the point. 0.64. What is the ratio of the Gross enrolment ratio (%) in Primary schools in Antigua and Barbuda to that in Argentina?
Make the answer very short. 1.08. What is the ratio of the Gross enrolment ratio (%) in Secondary schools in Antigua and Barbuda to that in Argentina?
Offer a very short reply. 1.45. What is the ratio of the Gross enrolment ratio (%) in Tertiary schools in Antigua and Barbuda to that in Argentina?
Offer a terse response. 1.17. What is the difference between the highest and the second highest Gross enrolment ratio (%) of Pre-primary schools?
Ensure brevity in your answer.  12.43. What is the difference between the highest and the second highest Gross enrolment ratio (%) in Primary schools?
Keep it short and to the point. 7.82. What is the difference between the highest and the second highest Gross enrolment ratio (%) of Secondary schools?
Your response must be concise. 6.88. What is the difference between the highest and the second highest Gross enrolment ratio (%) in Tertiary schools?
Your answer should be compact. 24.41. What is the difference between the highest and the lowest Gross enrolment ratio (%) of Pre-primary schools?
Make the answer very short. 39.81. What is the difference between the highest and the lowest Gross enrolment ratio (%) in Primary schools?
Offer a terse response. 41.03. What is the difference between the highest and the lowest Gross enrolment ratio (%) in Secondary schools?
Your response must be concise. 55.6. What is the difference between the highest and the lowest Gross enrolment ratio (%) in Tertiary schools?
Make the answer very short. 47.61. 